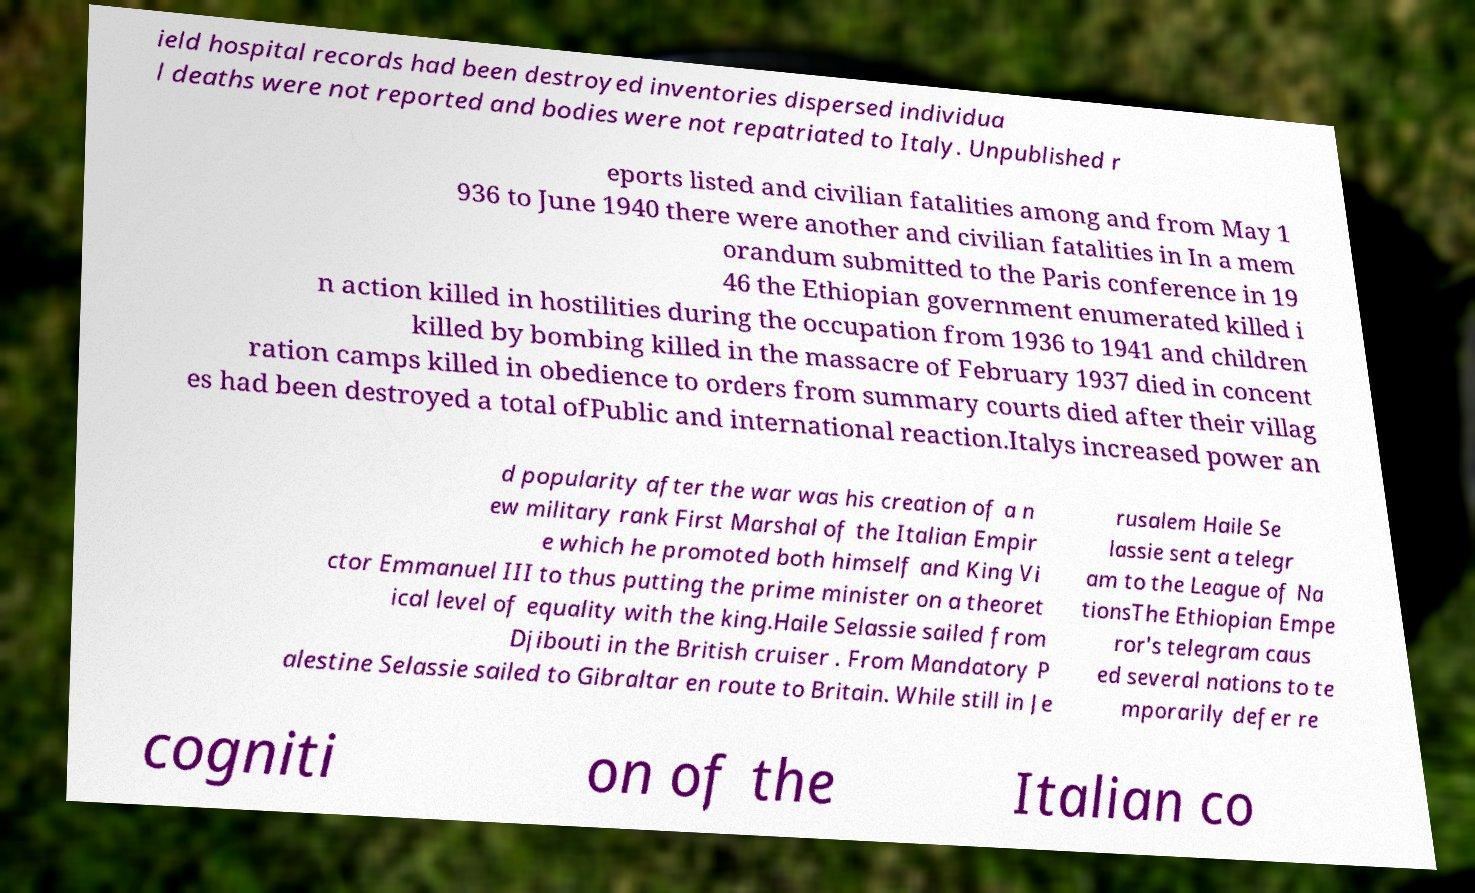There's text embedded in this image that I need extracted. Can you transcribe it verbatim? ield hospital records had been destroyed inventories dispersed individua l deaths were not reported and bodies were not repatriated to Italy. Unpublished r eports listed and civilian fatalities among and from May 1 936 to June 1940 there were another and civilian fatalities in In a mem orandum submitted to the Paris conference in 19 46 the Ethiopian government enumerated killed i n action killed in hostilities during the occupation from 1936 to 1941 and children killed by bombing killed in the massacre of February 1937 died in concent ration camps killed in obedience to orders from summary courts died after their villag es had been destroyed a total ofPublic and international reaction.Italys increased power an d popularity after the war was his creation of a n ew military rank First Marshal of the Italian Empir e which he promoted both himself and King Vi ctor Emmanuel III to thus putting the prime minister on a theoret ical level of equality with the king.Haile Selassie sailed from Djibouti in the British cruiser . From Mandatory P alestine Selassie sailed to Gibraltar en route to Britain. While still in Je rusalem Haile Se lassie sent a telegr am to the League of Na tionsThe Ethiopian Empe ror's telegram caus ed several nations to te mporarily defer re cogniti on of the Italian co 